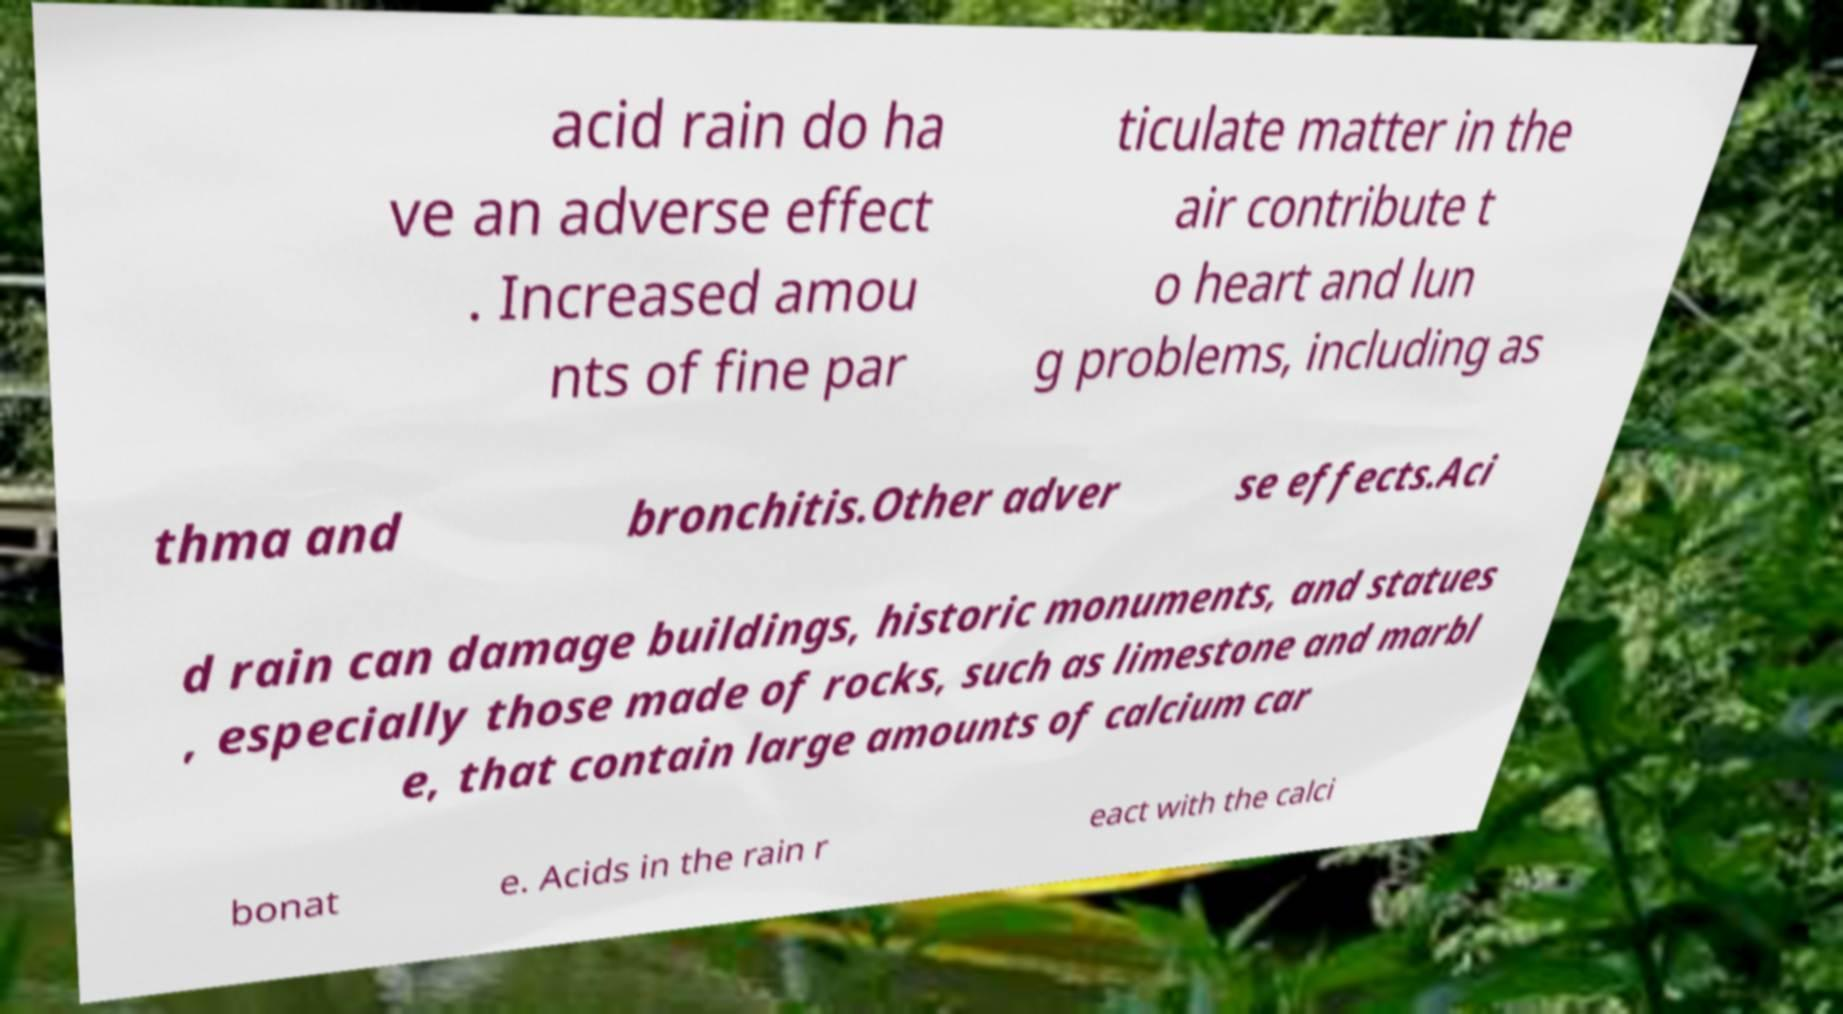Could you extract and type out the text from this image? acid rain do ha ve an adverse effect . Increased amou nts of fine par ticulate matter in the air contribute t o heart and lun g problems, including as thma and bronchitis.Other adver se effects.Aci d rain can damage buildings, historic monuments, and statues , especially those made of rocks, such as limestone and marbl e, that contain large amounts of calcium car bonat e. Acids in the rain r eact with the calci 